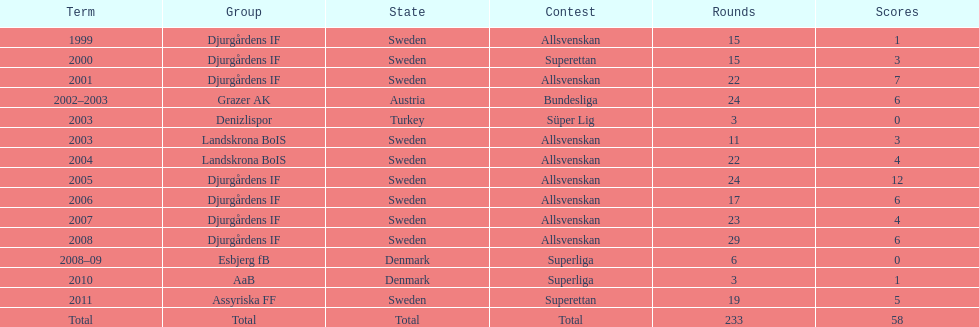What team has the most goals? Djurgårdens IF. 